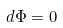Convert formula to latex. <formula><loc_0><loc_0><loc_500><loc_500>d \Phi = 0</formula> 